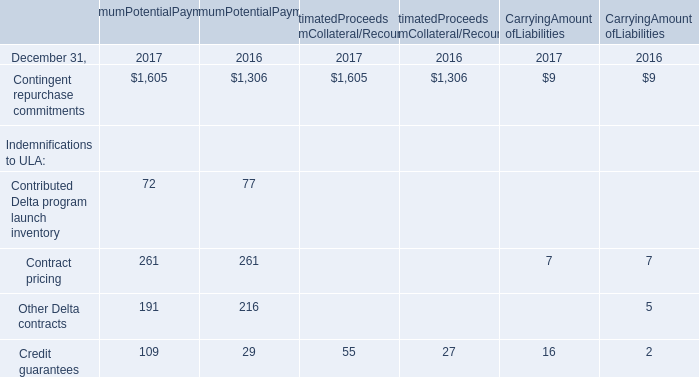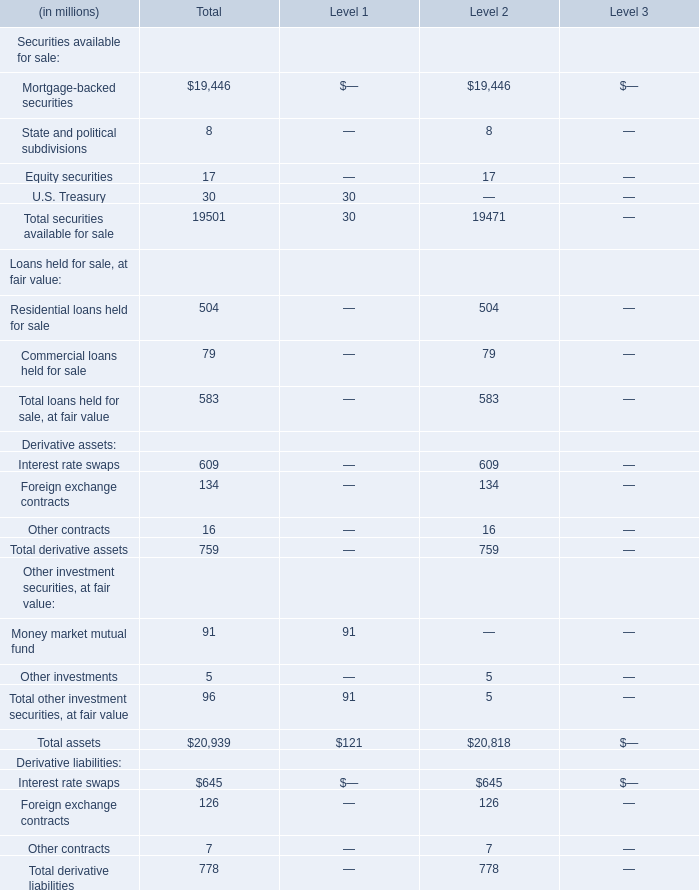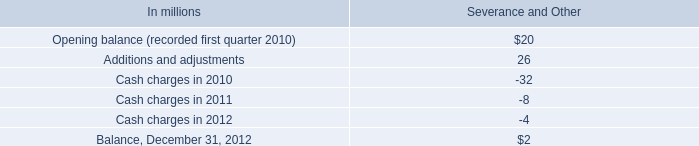what was the total approximate number of shares international paper acquired of the outstanding common stock of temple-inland 
Computations: (3.7 / 32)
Answer: 0.11563. 